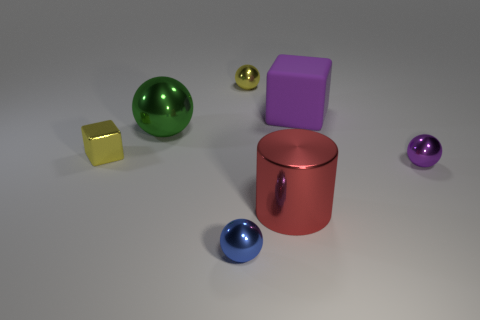Add 3 tiny blue rubber balls. How many objects exist? 10 Subtract all cylinders. How many objects are left? 6 Add 1 small yellow metal spheres. How many small yellow metal spheres exist? 2 Subtract 1 yellow balls. How many objects are left? 6 Subtract all big green matte objects. Subtract all small shiny spheres. How many objects are left? 4 Add 1 big objects. How many big objects are left? 4 